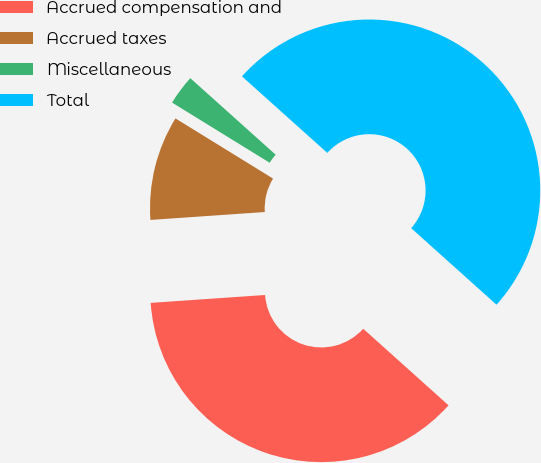Convert chart to OTSL. <chart><loc_0><loc_0><loc_500><loc_500><pie_chart><fcel>Accrued compensation and<fcel>Accrued taxes<fcel>Miscellaneous<fcel>Total<nl><fcel>37.26%<fcel>9.89%<fcel>2.84%<fcel>50.0%<nl></chart> 